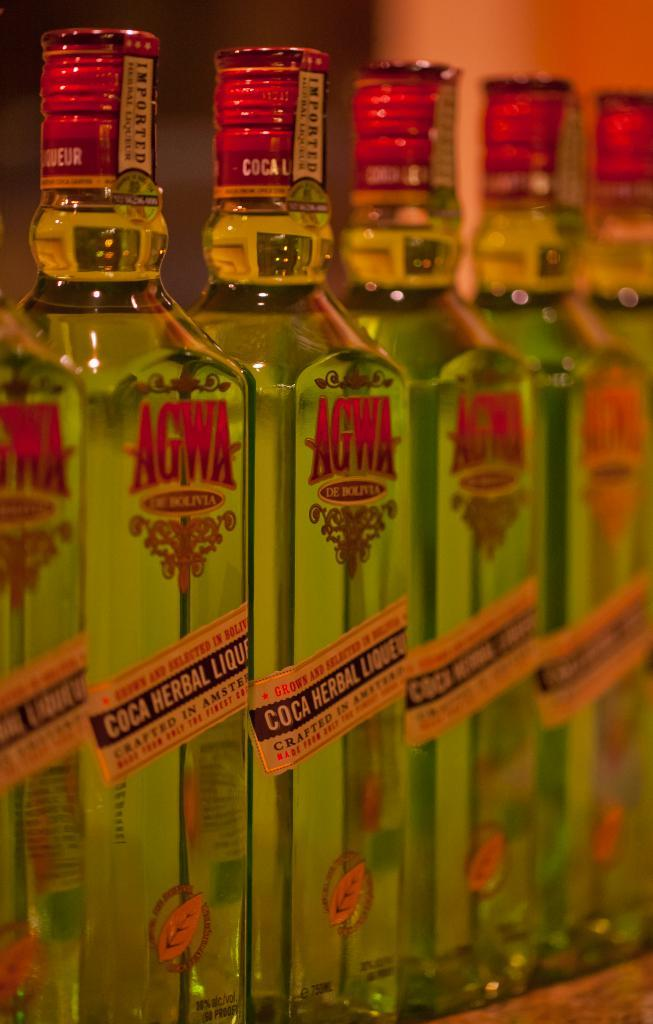<image>
Relay a brief, clear account of the picture shown. Several imported bottles of Agwa De Bolivia appear to be unopened. 